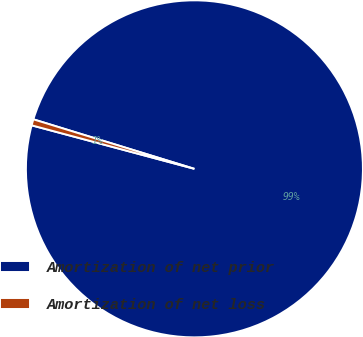Convert chart to OTSL. <chart><loc_0><loc_0><loc_500><loc_500><pie_chart><fcel>Amortization of net prior<fcel>Amortization of net loss<nl><fcel>99.41%<fcel>0.59%<nl></chart> 